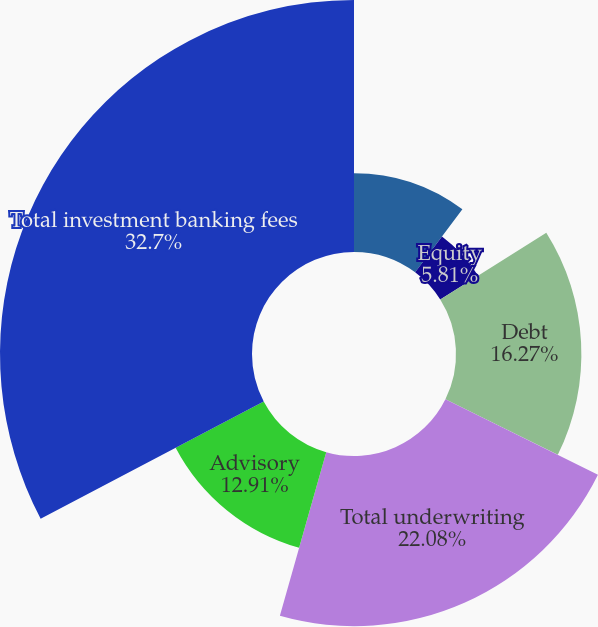Convert chart. <chart><loc_0><loc_0><loc_500><loc_500><pie_chart><fcel>Year ended December 31 (in<fcel>Equity<fcel>Debt<fcel>Total underwriting<fcel>Advisory<fcel>Total investment banking fees<nl><fcel>10.23%<fcel>5.81%<fcel>16.27%<fcel>22.08%<fcel>12.91%<fcel>32.7%<nl></chart> 